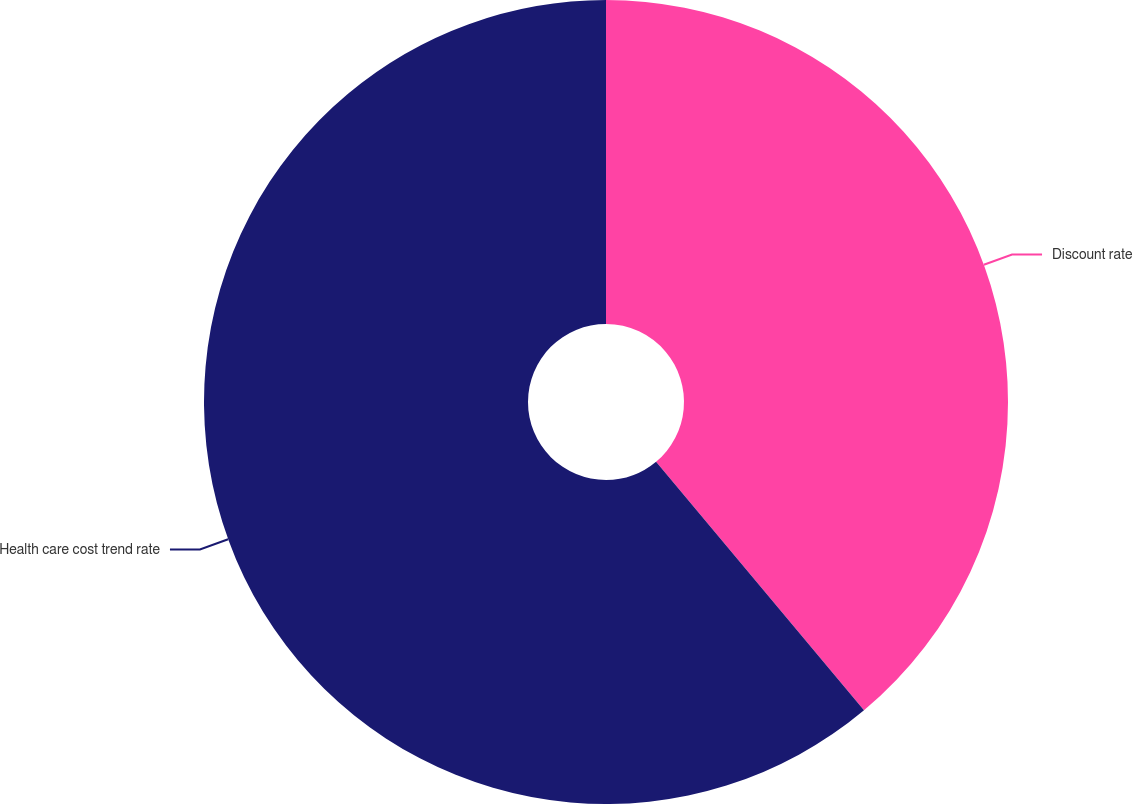<chart> <loc_0><loc_0><loc_500><loc_500><pie_chart><fcel>Discount rate<fcel>Health care cost trend rate<nl><fcel>38.91%<fcel>61.09%<nl></chart> 